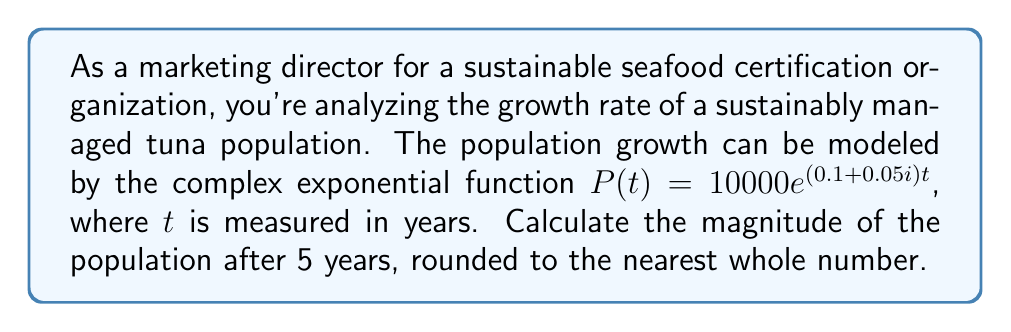Show me your answer to this math problem. To solve this problem, we need to follow these steps:

1) The given function is $P(t) = 10000e^{(0.1 + 0.05i)t}$

2) We need to find $|P(5)|$, which is the magnitude of $P(t)$ when $t = 5$

3) First, let's calculate $P(5)$:

   $P(5) = 10000e^{(0.1 + 0.05i)5}$
   $= 10000e^{0.5 + 0.25i}$

4) To find the magnitude of this complex number, we use the formula $|e^{a+bi}| = e^a$

5) In our case, $a = 0.5$ and $b = 0.25$

6) Therefore, 
   $|P(5)| = 10000|e^{0.5 + 0.25i}| = 10000e^{0.5}$

7) Now we can calculate this:
   $|P(5)| = 10000e^{0.5} \approx 16487.21$

8) Rounding to the nearest whole number gives us 16487

This result represents the estimated tuna population after 5 years according to the given model.
Answer: 16487 